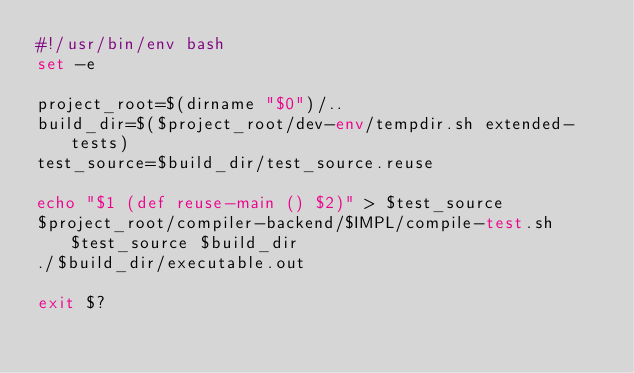Convert code to text. <code><loc_0><loc_0><loc_500><loc_500><_Bash_>#!/usr/bin/env bash
set -e

project_root=$(dirname "$0")/..
build_dir=$($project_root/dev-env/tempdir.sh extended-tests)
test_source=$build_dir/test_source.reuse

echo "$1 (def reuse-main () $2)" > $test_source
$project_root/compiler-backend/$IMPL/compile-test.sh $test_source $build_dir
./$build_dir/executable.out

exit $?
</code> 